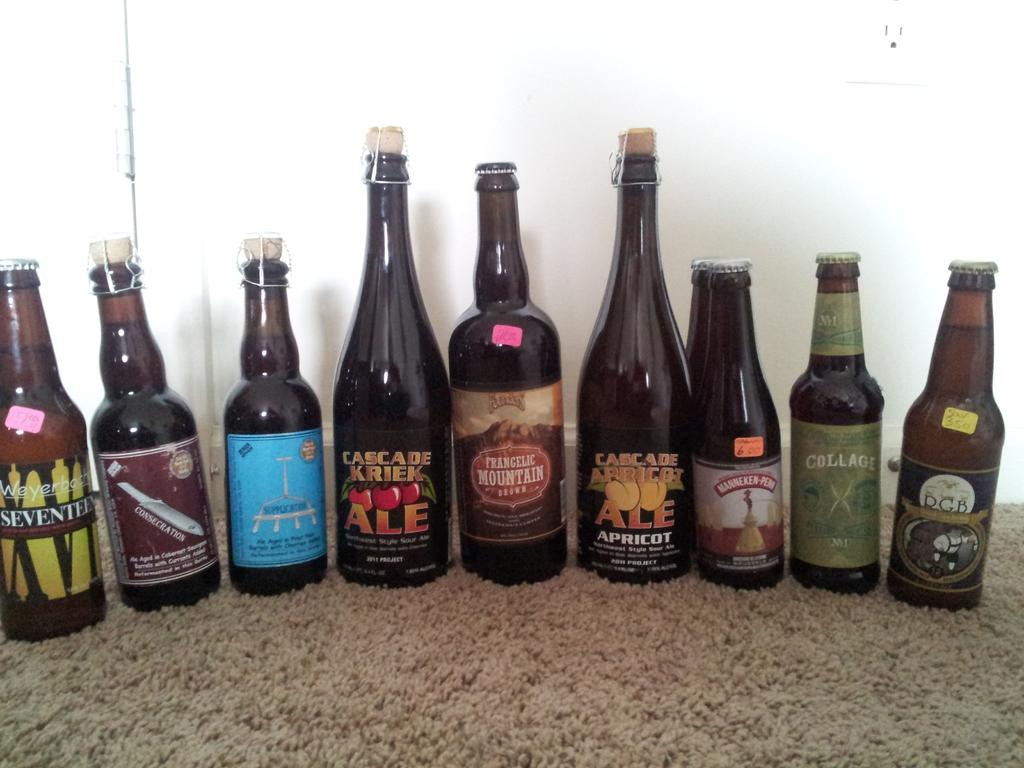What is the brand of the bottle in the center?
Offer a terse response. Frangelic mountain. 